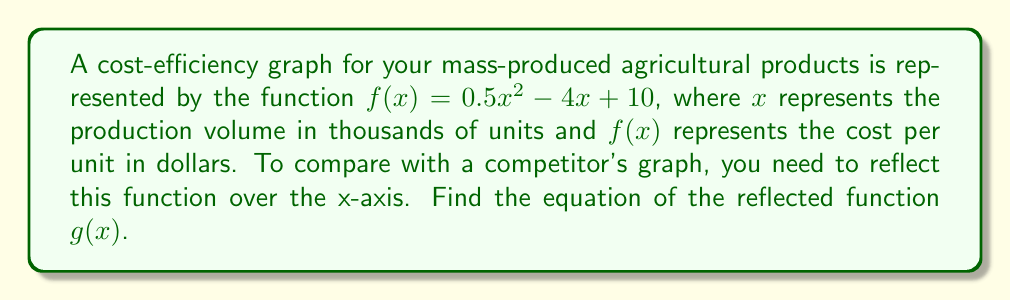Provide a solution to this math problem. To reflect a function over the x-axis, we need to negate the entire function. This means multiplying the original function by -1.

Step 1: Start with the original function
$f(x) = 0.5x^2 - 4x + 10$

Step 2: Multiply the entire function by -1
$g(x) = -(0.5x^2 - 4x + 10)$

Step 3: Distribute the negative sign
$g(x) = -0.5x^2 + 4x - 10$

The resulting function $g(x)$ is the reflection of $f(x)$ over the x-axis. This new function will have the same shape as the original, but inverted vertically. It can be used to visually compare your cost-efficiency with that of your competitors.
Answer: $g(x) = -0.5x^2 + 4x - 10$ 